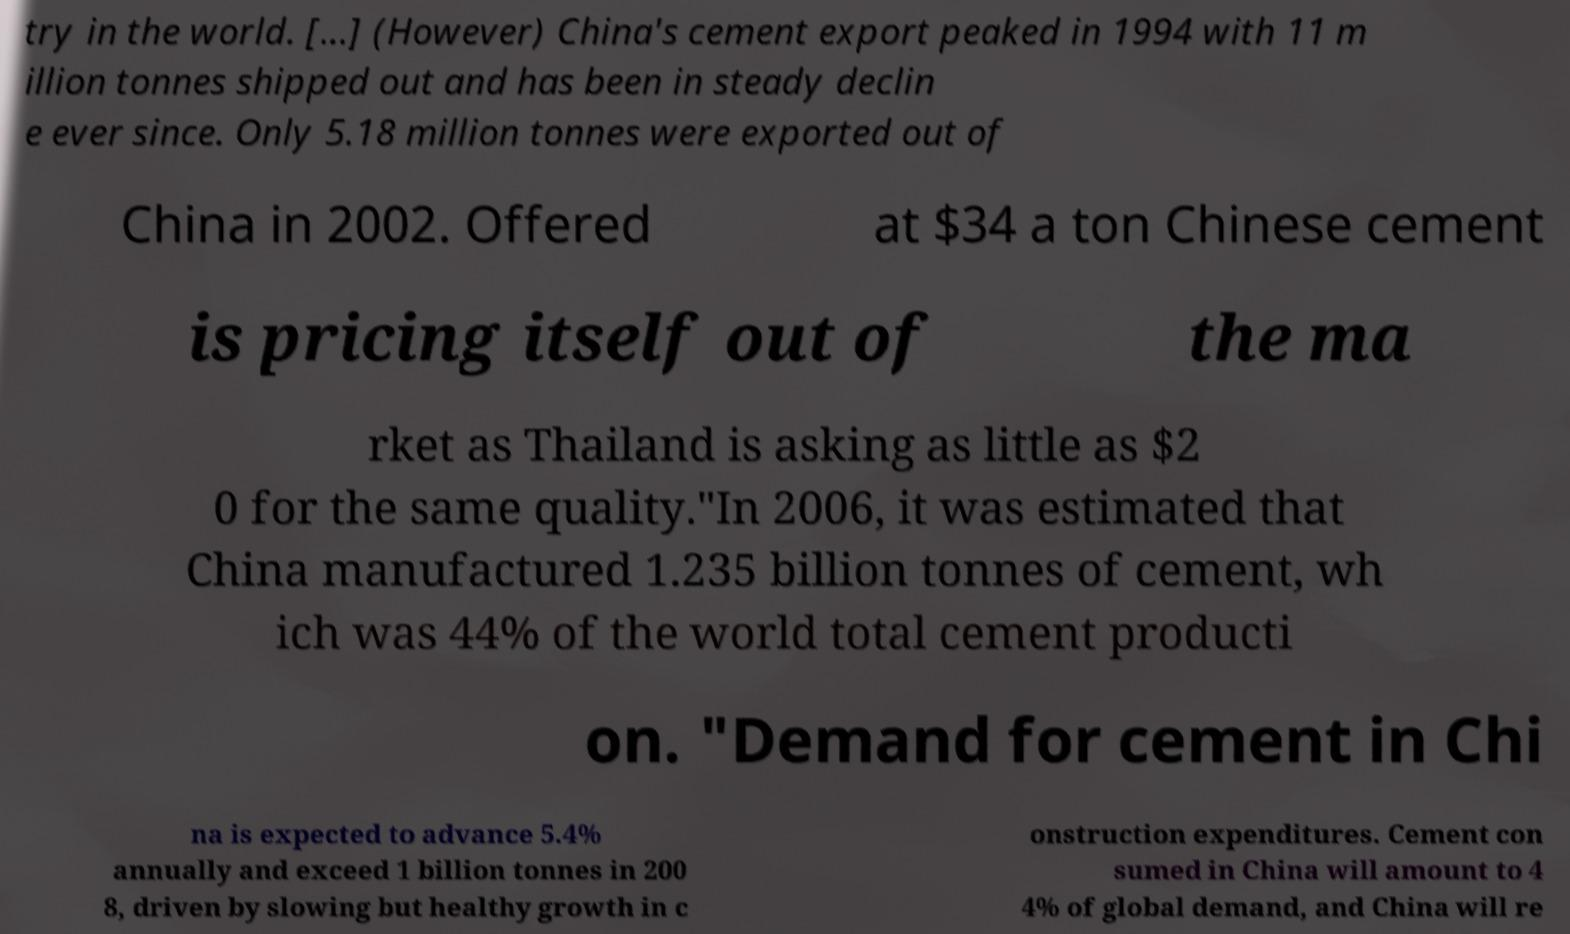Please identify and transcribe the text found in this image. try in the world. [...] (However) China's cement export peaked in 1994 with 11 m illion tonnes shipped out and has been in steady declin e ever since. Only 5.18 million tonnes were exported out of China in 2002. Offered at $34 a ton Chinese cement is pricing itself out of the ma rket as Thailand is asking as little as $2 0 for the same quality."In 2006, it was estimated that China manufactured 1.235 billion tonnes of cement, wh ich was 44% of the world total cement producti on. "Demand for cement in Chi na is expected to advance 5.4% annually and exceed 1 billion tonnes in 200 8, driven by slowing but healthy growth in c onstruction expenditures. Cement con sumed in China will amount to 4 4% of global demand, and China will re 